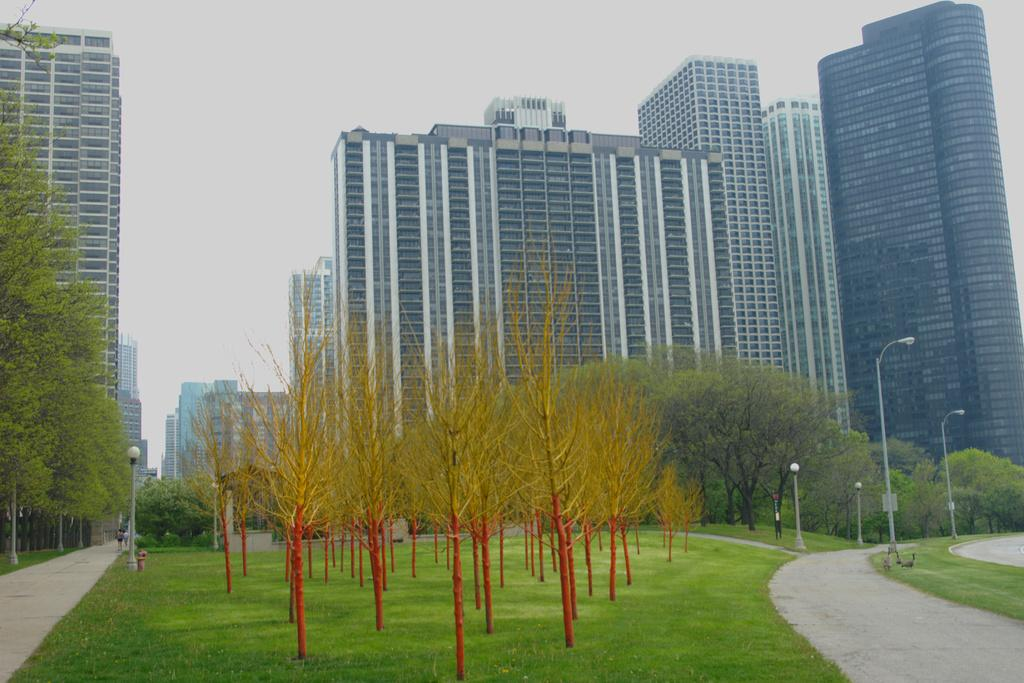What type of vegetation is present in the image? There are many trees in the image. What structures can be seen in the image? A: There are light poles and buildings in the image. What type of ground surface is visible in the image? There is grass on the ground in the image. What can be seen in the background of the image? There are buildings and the sky visible in the background of the image. What type of vessel is being developed in the image? There is no vessel being developed in the image; it features trees, light poles, roads, grass, buildings, and the sky. Can you provide an example of a development project in the image? There is no specific development project mentioned or depicted in the image. 